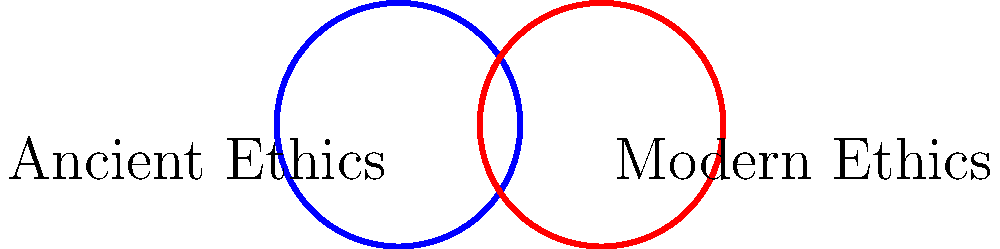In the diagram, ancient and modern ethical frameworks are represented by overlapping circles. What does the purple intersection area signify, and how might this visualization inform our understanding of ethical continuity and evolution? To answer this question, let's analyze the diagram step-by-step:

1. The blue circle represents ancient ethical frameworks, while the red circle represents modern ethical frameworks.

2. The overlapping area (purple) between these two circles represents shared principles or concepts that exist in both ancient and modern ethics.

3. This intersection suggests that there is continuity in ethical thought across time, despite societal and cultural changes.

4. The presence of non-overlapping areas in both circles indicates that there are also unique aspects to both ancient and modern ethics, reflecting the evolution of ethical thinking.

5. The roughly equal size of the circles implies that both ancient and modern ethics have comparable complexity and depth.

6. The substantial overlap suggests that many fundamental ethical principles have remained consistent over time.

7. This visualization helps us understand that:
   a) Ethical thought is not entirely reinvented in modern times but builds upon ancient foundations.
   b) There is a dialogue between past and present ethical frameworks.
   c) Some ethical principles appear to be universal or timeless.

8. From a philosophical perspective, this overlap challenges the notion of ethical relativism by showing common ground across different time periods.

9. It also invites us to consider which specific principles might occupy this shared space (e.g., concepts of justice, virtue, or human dignity).

10. The diagram encourages us to reflect on the nature of ethical progress: Is it a complete departure from the past or a refinement and expansion of enduring principles?
Answer: Shared ethical principles persisting through time, demonstrating both continuity and evolution in moral philosophy. 